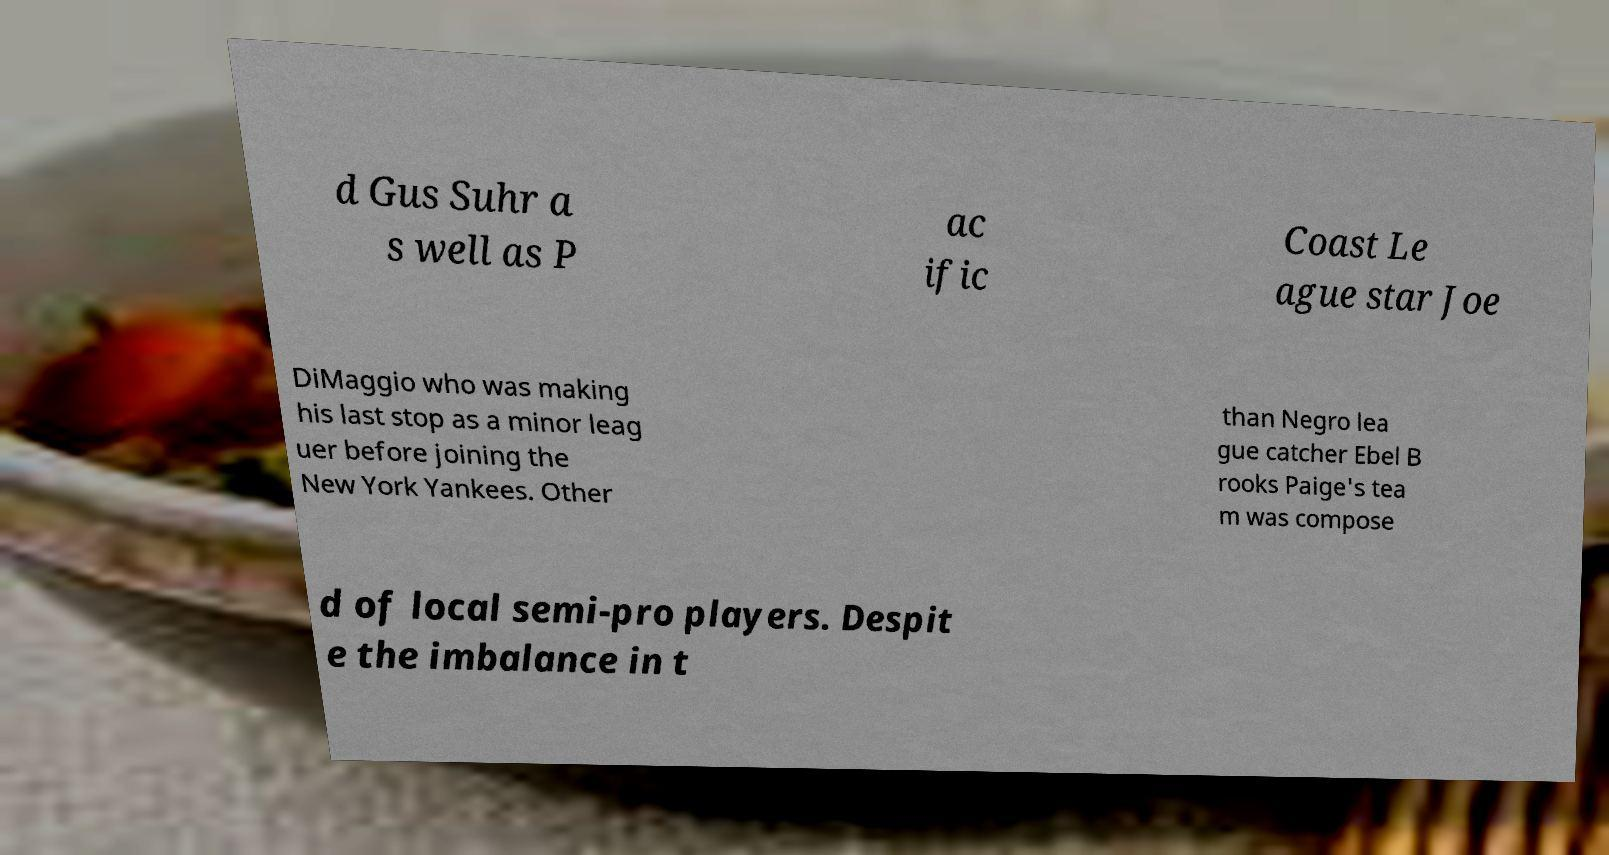Could you assist in decoding the text presented in this image and type it out clearly? d Gus Suhr a s well as P ac ific Coast Le ague star Joe DiMaggio who was making his last stop as a minor leag uer before joining the New York Yankees. Other than Negro lea gue catcher Ebel B rooks Paige's tea m was compose d of local semi-pro players. Despit e the imbalance in t 